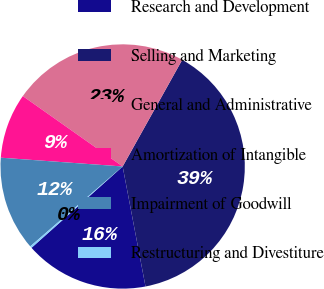Convert chart to OTSL. <chart><loc_0><loc_0><loc_500><loc_500><pie_chart><fcel>Research and Development<fcel>Selling and Marketing<fcel>General and Administrative<fcel>Amortization of Intangible<fcel>Impairment of Goodwill<fcel>Restructuring and Divestiture<nl><fcel>16.4%<fcel>38.9%<fcel>23.33%<fcel>8.63%<fcel>12.49%<fcel>0.25%<nl></chart> 